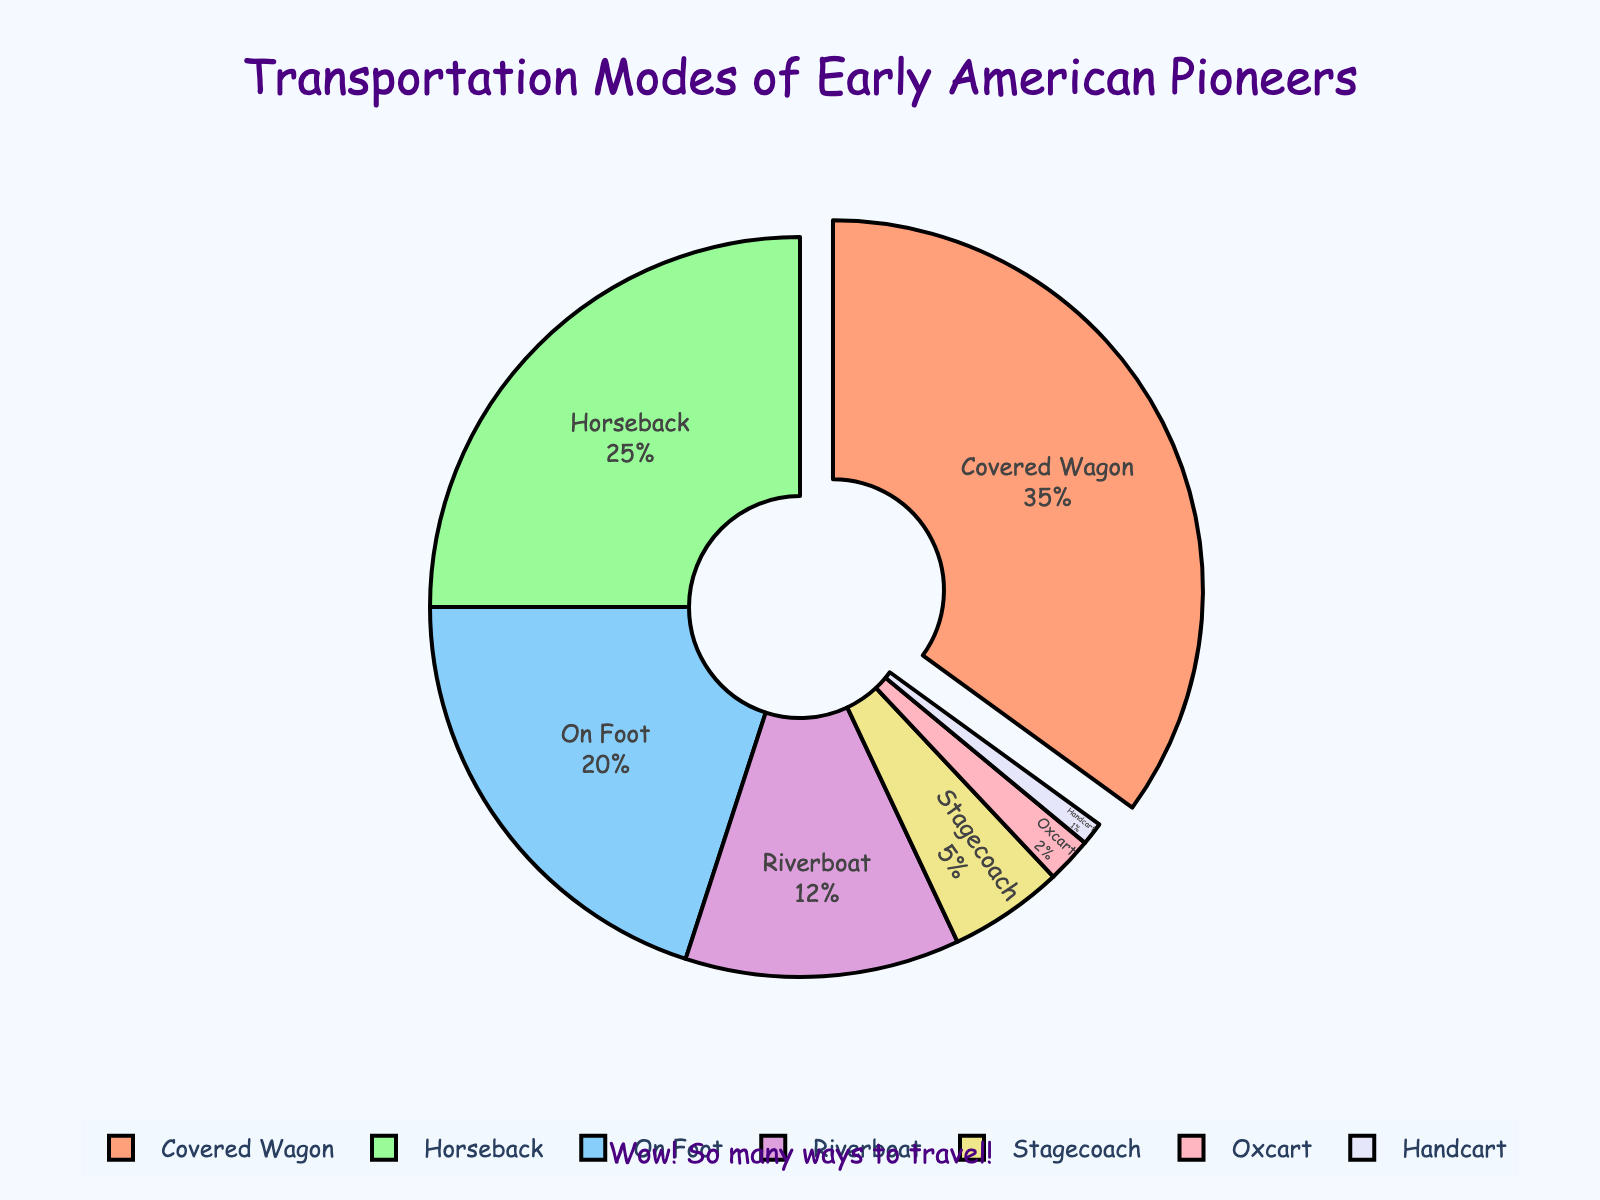What is the most popular mode of transportation used by the early American pioneers? The covered wagon has the highest percentage of 35, making it the most popular mode of transportation among the pioneers.
Answer: Covered Wagon Which mode of transportation was used by the least number of pioneers? The handcart has the smallest percentage of 1, indicating it was used by the least number of pioneers.
Answer: Handcart How much more popular is traveling by covered wagon compared to traveling by stagecoach? The percentage for the covered wagon is 35, and for the stagecoach, it is 5. The difference is 35 - 5 = 30 percentage points.
Answer: 30 What is the total percentage of pioneers who traveled by either riverboat or stagecoach? The percentage for riverboat is 12, and for stagecoach, it is 5. Adding these together gives 12 + 5 = 17 percent.
Answer: 17 Is traveling on horseback more popular than traveling on foot? The percentage for horseback is 25, while on foot is 20. Since 25 is greater than 20, traveling on horseback is more popular.
Answer: Yes If you combine the percentages of oxcart and handcart, does it exceed the percentage of riverboat? The percentage for oxcart is 2, and for handcart, it is 1. Summing these gives 2 + 1 = 3, which is less than the riverboat percentage of 12.
Answer: No What fraction of the total percentage does the stagecoach mode of transportation represent? The total percentage of transportation modes represented in the pie chart is 100%. Stagecoach makes up 5%, so it represents 5/100 or 1/20 of the total.
Answer: 1/20 How many modes of transportation have a percentage of 10 or more? The percentages over 10 are covered wagon (35), horseback (25), on foot (20), and riverboat (12). There are four such modes.
Answer: 4 What is the combined percentage of the three least-used modes of transportation? The least-used modes are handcart (1%), oxcart (2%), and stagecoach (5%). Adding these gives 1 + 2 + 5 = 8 percent.
Answer: 8 What colors are used to represent the two most popular modes of transportation? The covered wagon (most popular) is represented by a color similar to light salmon (35%), and horseback (second most popular) is represented by a color similar to pale green (25%).
Answer: Light salmon and pale green 